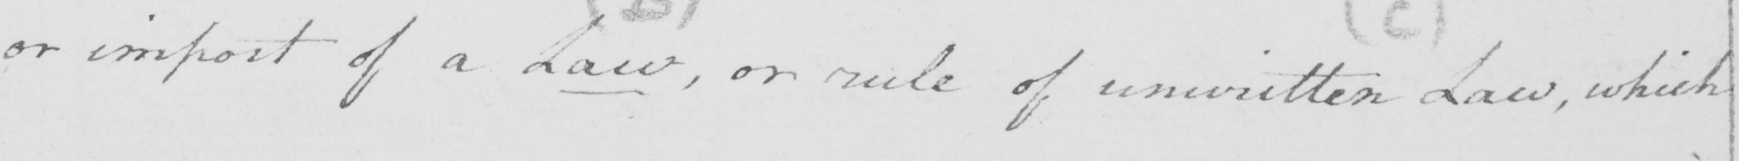Transcribe the text shown in this historical manuscript line. or import of a Law  , or rule of unwritten Law , which 